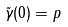Convert formula to latex. <formula><loc_0><loc_0><loc_500><loc_500>\tilde { \gamma } ( 0 ) = p</formula> 